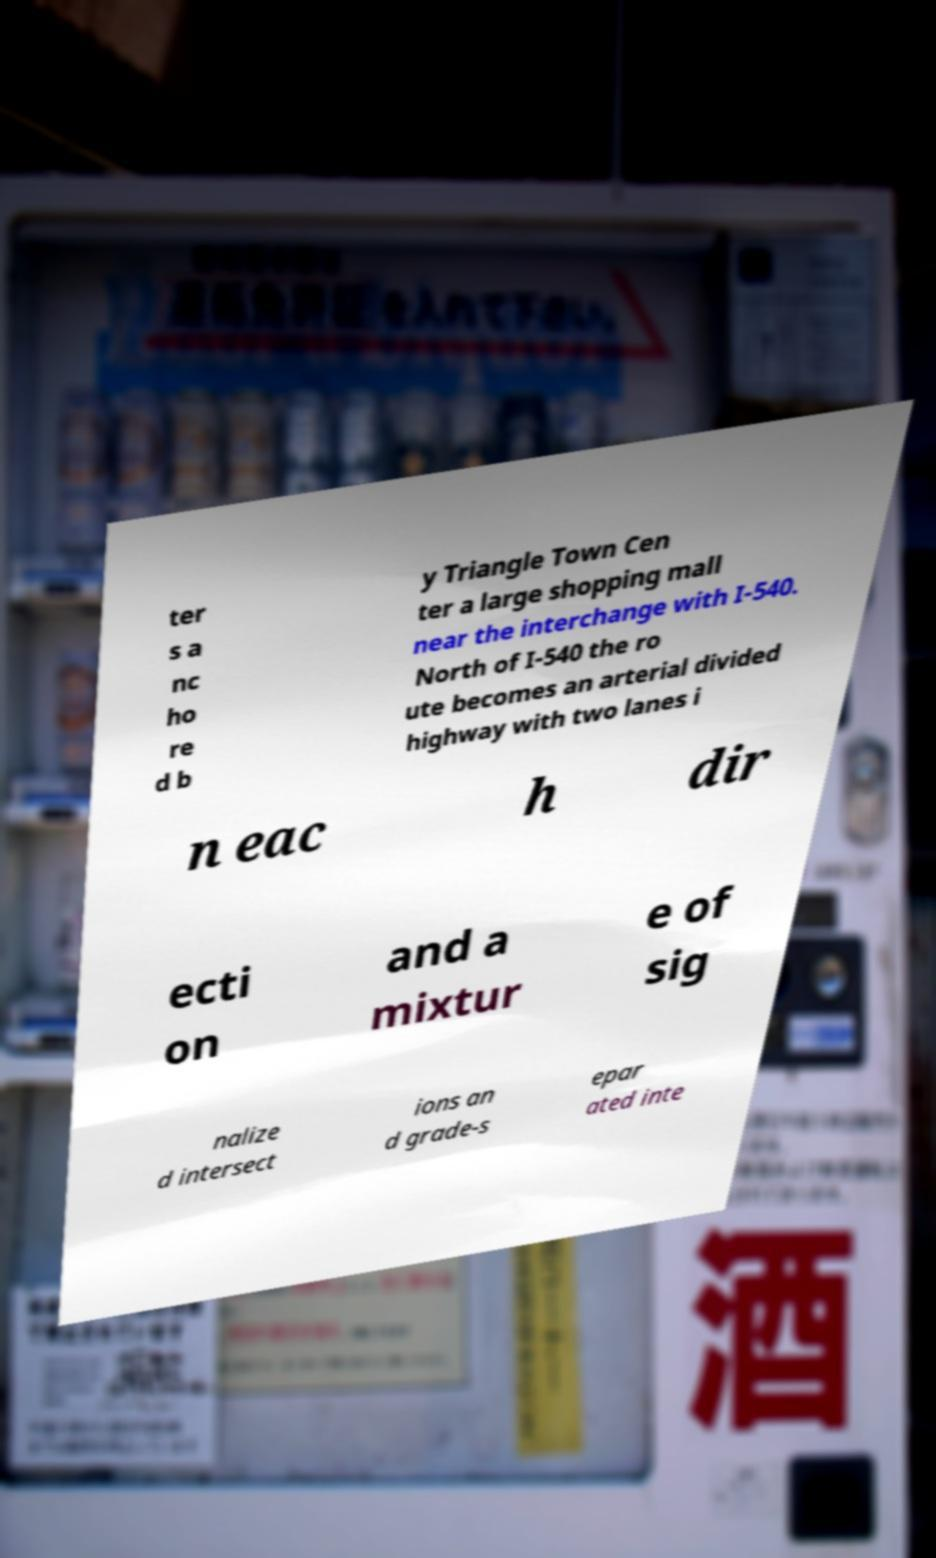Could you assist in decoding the text presented in this image and type it out clearly? ter s a nc ho re d b y Triangle Town Cen ter a large shopping mall near the interchange with I-540. North of I-540 the ro ute becomes an arterial divided highway with two lanes i n eac h dir ecti on and a mixtur e of sig nalize d intersect ions an d grade-s epar ated inte 